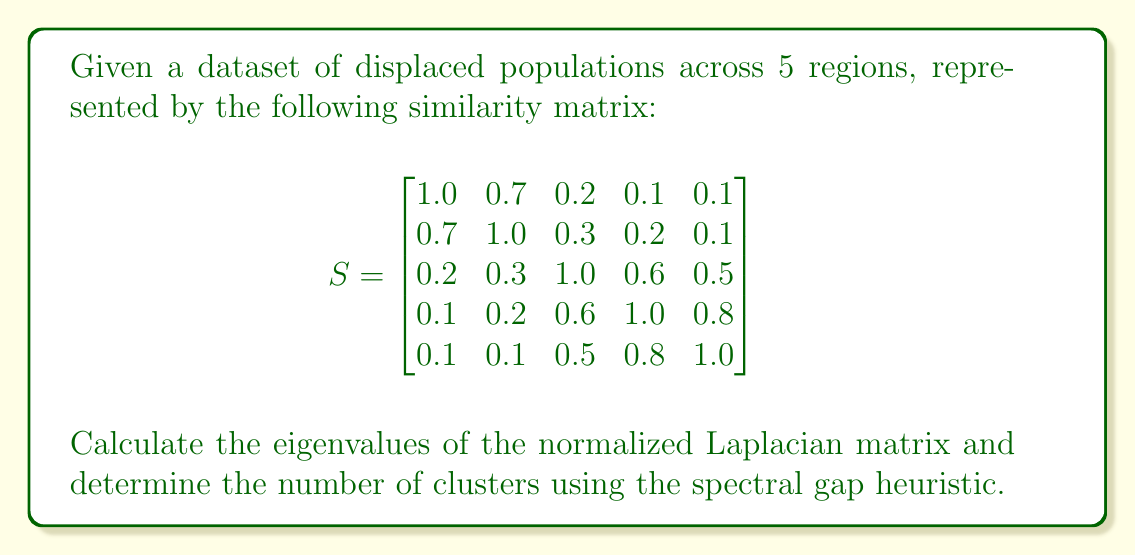What is the answer to this math problem? 1. Compute the degree matrix $D$:
   $$D = \text{diag}(2.1, 2.3, 2.6, 2.7, 2.5)$$

2. Calculate the normalized Laplacian matrix $L_{\text{sym}}$:
   $$L_{\text{sym}} = I - D^{-1/2}SD^{-1/2}$$

3. Compute $D^{-1/2}$:
   $$D^{-1/2} = \text{diag}(1/\sqrt{2.1}, 1/\sqrt{2.3}, 1/\sqrt{2.6}, 1/\sqrt{2.7}, 1/\sqrt{2.5})$$

4. Calculate $L_{\text{sym}}$ (rounded to 4 decimal places):
   $$L_{\text{sym}} = \begin{bmatrix}
   1.0000 & -0.4472 & -0.1195 & -0.0589 & -0.0612 \\
   -0.4472 & 1.0000 & -0.1782 & -0.1168 & -0.0606 \\
   -0.1195 & -0.1782 & 1.0000 & -0.3536 & -0.3062 \\
   -0.0589 & -0.1168 & -0.3536 & 1.0000 & -0.4899 \\
   -0.0612 & -0.0606 & -0.3062 & -0.4899 & 1.0000
   \end{bmatrix}$$

5. Compute the eigenvalues of $L_{\text{sym}}$ (rounded to 4 decimal places):
   $$\lambda_1 = 0.0000, \lambda_2 = 0.2689, \lambda_3 = 0.5000, \lambda_4 = 1.0000, \lambda_5 = 2.2311$$

6. Apply the spectral gap heuristic:
   The largest gap is between $\lambda_2$ and $\lambda_3$, suggesting 2 clusters.
Answer: 2 clusters 